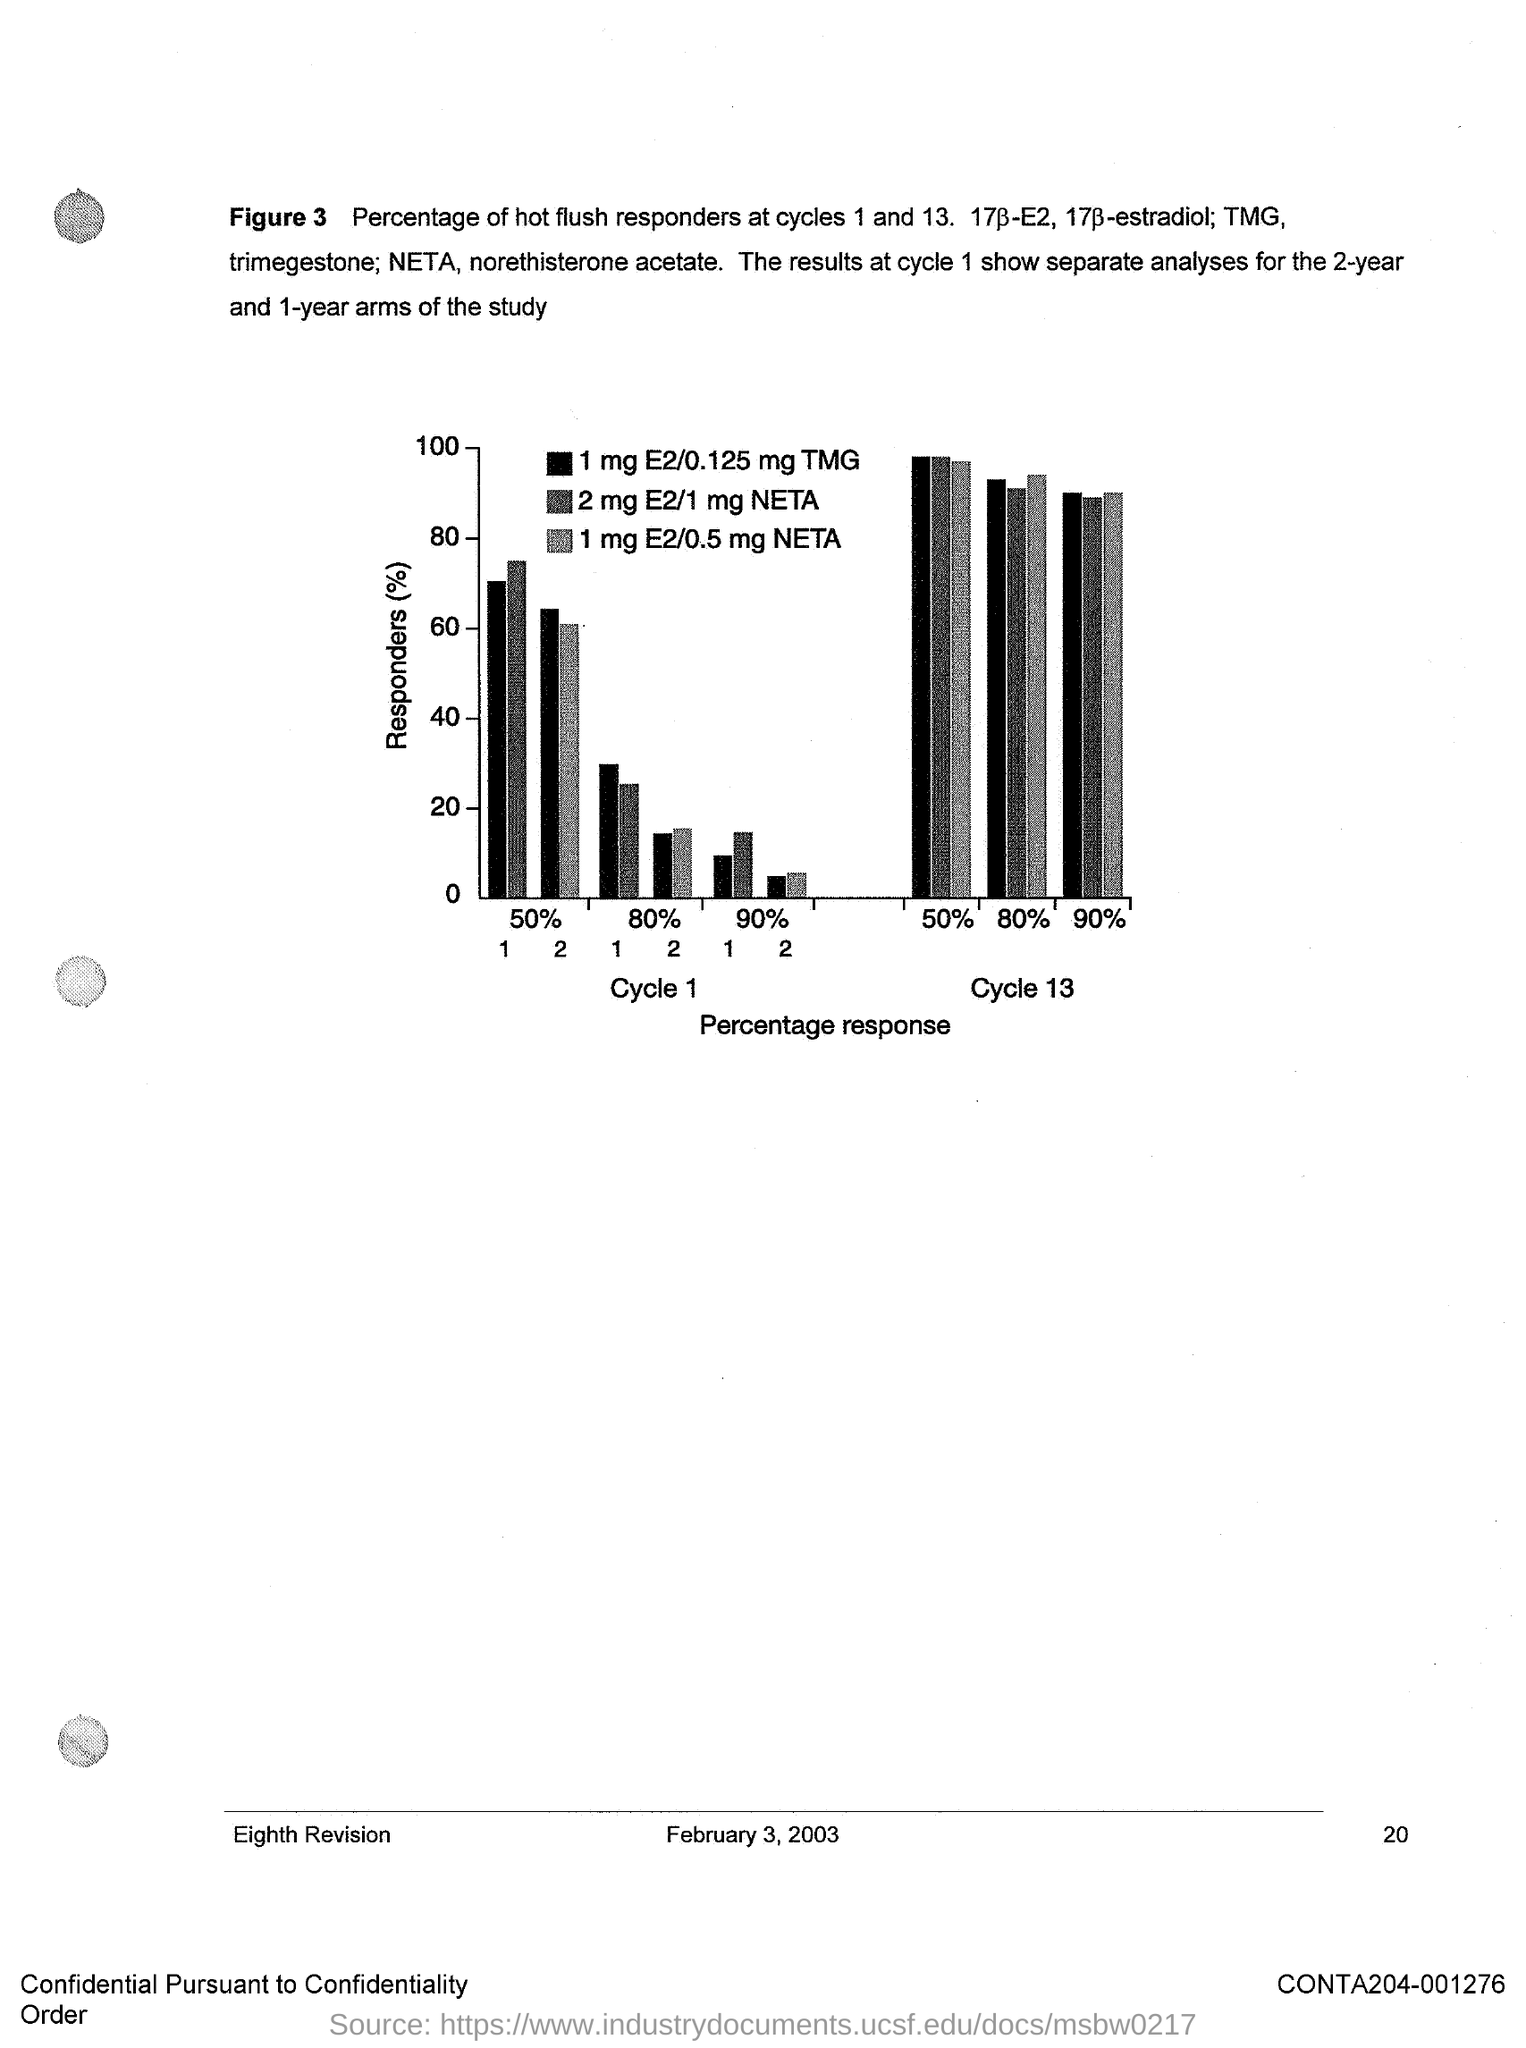Outline some significant characteristics in this image. The y-axis of Figure 3 represents the percentage of responders. The x-axis of Figure 3 represents the percentage of response. The document in question contains the date of February 3, 2003. Figure 3 illustrates the percentage of hot flush responders at cycles 1 and 13, which demonstrates the effectiveness of the intervention in reducing hot flushes over time. 